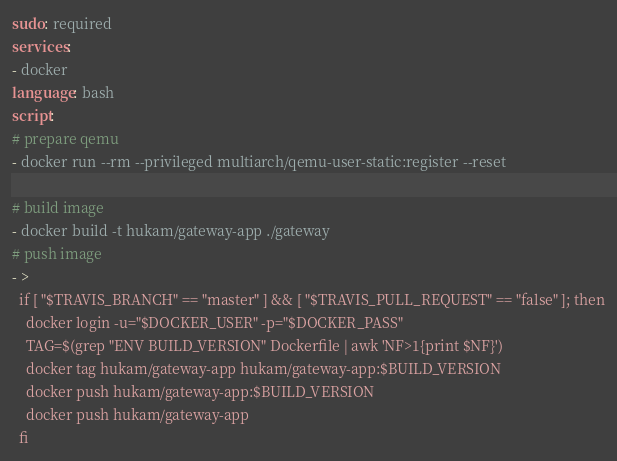<code> <loc_0><loc_0><loc_500><loc_500><_YAML_>sudo: required
services:
- docker
language: bash
script:
# prepare qemu
- docker run --rm --privileged multiarch/qemu-user-static:register --reset

# build image
- docker build -t hukam/gateway-app ./gateway
# push image
- >
  if [ "$TRAVIS_BRANCH" == "master" ] && [ "$TRAVIS_PULL_REQUEST" == "false" ]; then
    docker login -u="$DOCKER_USER" -p="$DOCKER_PASS"
    TAG=$(grep "ENV BUILD_VERSION" Dockerfile | awk 'NF>1{print $NF}')
    docker tag hukam/gateway-app hukam/gateway-app:$BUILD_VERSION
    docker push hukam/gateway-app:$BUILD_VERSION
    docker push hukam/gateway-app
  fi
</code> 